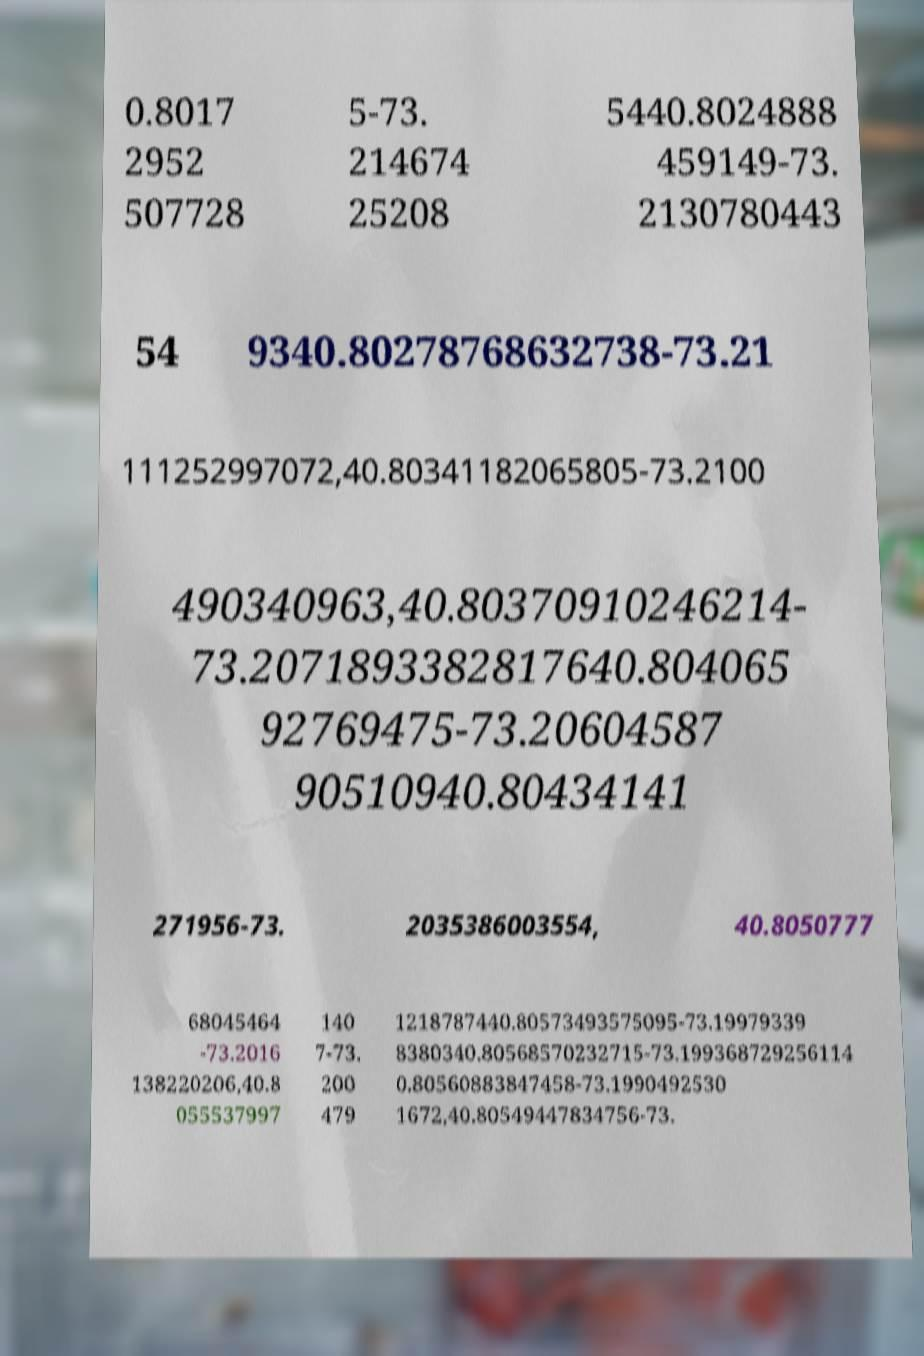Can you accurately transcribe the text from the provided image for me? 0.8017 2952 507728 5-73. 214674 25208 5440.8024888 459149-73. 2130780443 54 9340.80278768632738-73.21 111252997072,40.80341182065805-73.2100 490340963,40.80370910246214- 73.2071893382817640.804065 92769475-73.20604587 90510940.80434141 271956-73. 2035386003554, 40.8050777 68045464 -73.2016 138220206,40.8 055537997 140 7-73. 200 479 1218787440.80573493575095-73.19979339 8380340.80568570232715-73.199368729256114 0.80560883847458-73.1990492530 1672,40.80549447834756-73. 